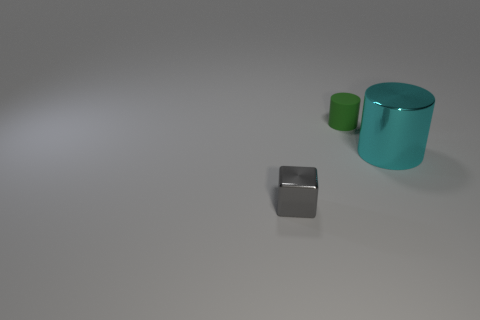Add 2 big purple cubes. How many objects exist? 5 Subtract all cubes. How many objects are left? 2 Add 1 large objects. How many large objects exist? 2 Subtract 0 red cylinders. How many objects are left? 3 Subtract all big yellow matte cylinders. Subtract all small gray metal objects. How many objects are left? 2 Add 3 cubes. How many cubes are left? 4 